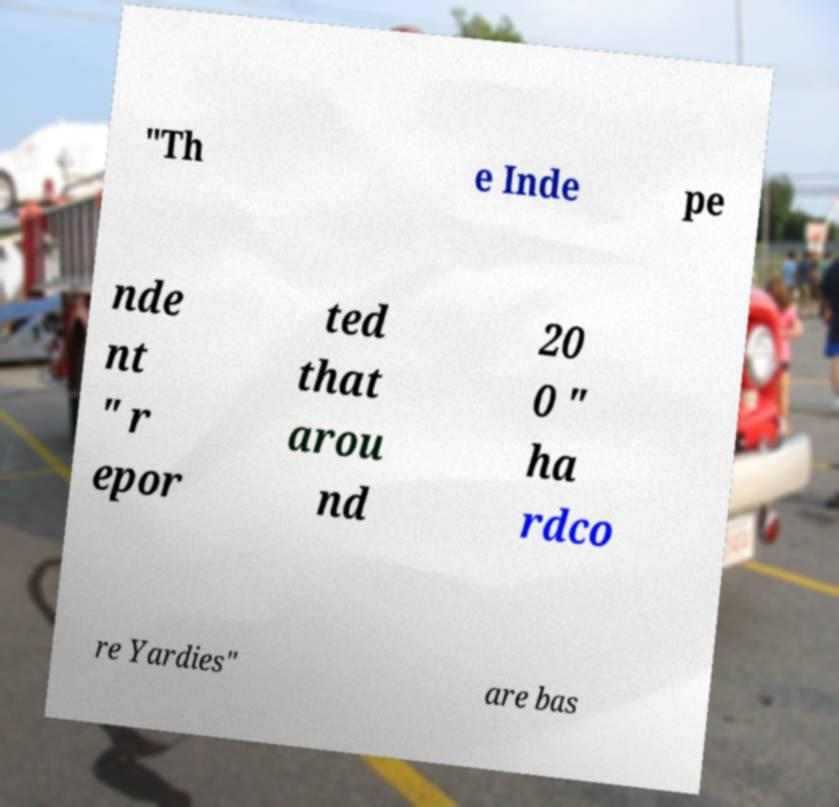I need the written content from this picture converted into text. Can you do that? "Th e Inde pe nde nt " r epor ted that arou nd 20 0 " ha rdco re Yardies" are bas 